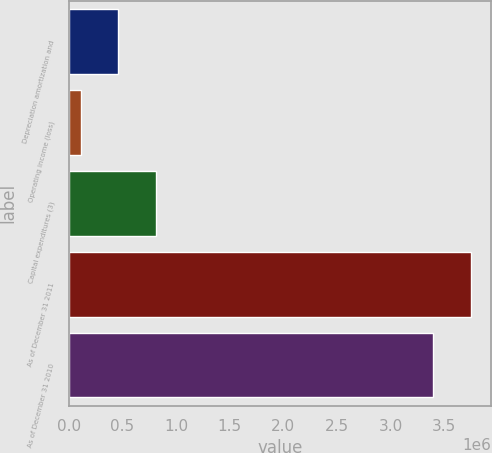Convert chart to OTSL. <chart><loc_0><loc_0><loc_500><loc_500><bar_chart><fcel>Depreciation amortization and<fcel>Operating income (loss)<fcel>Capital expenditures (3)<fcel>As of December 31 2011<fcel>As of December 31 2010<nl><fcel>460233<fcel>110659<fcel>809807<fcel>3.74975e+06<fcel>3.40018e+06<nl></chart> 